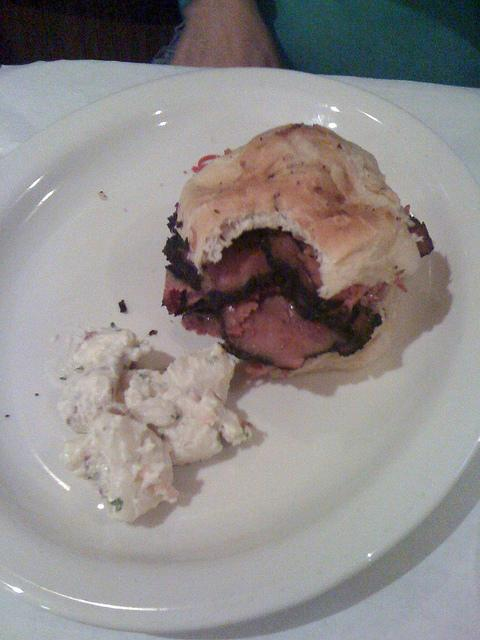What is the side dish?

Choices:
A) potato salad
B) beets
C) carrots
D) fries potato salad 